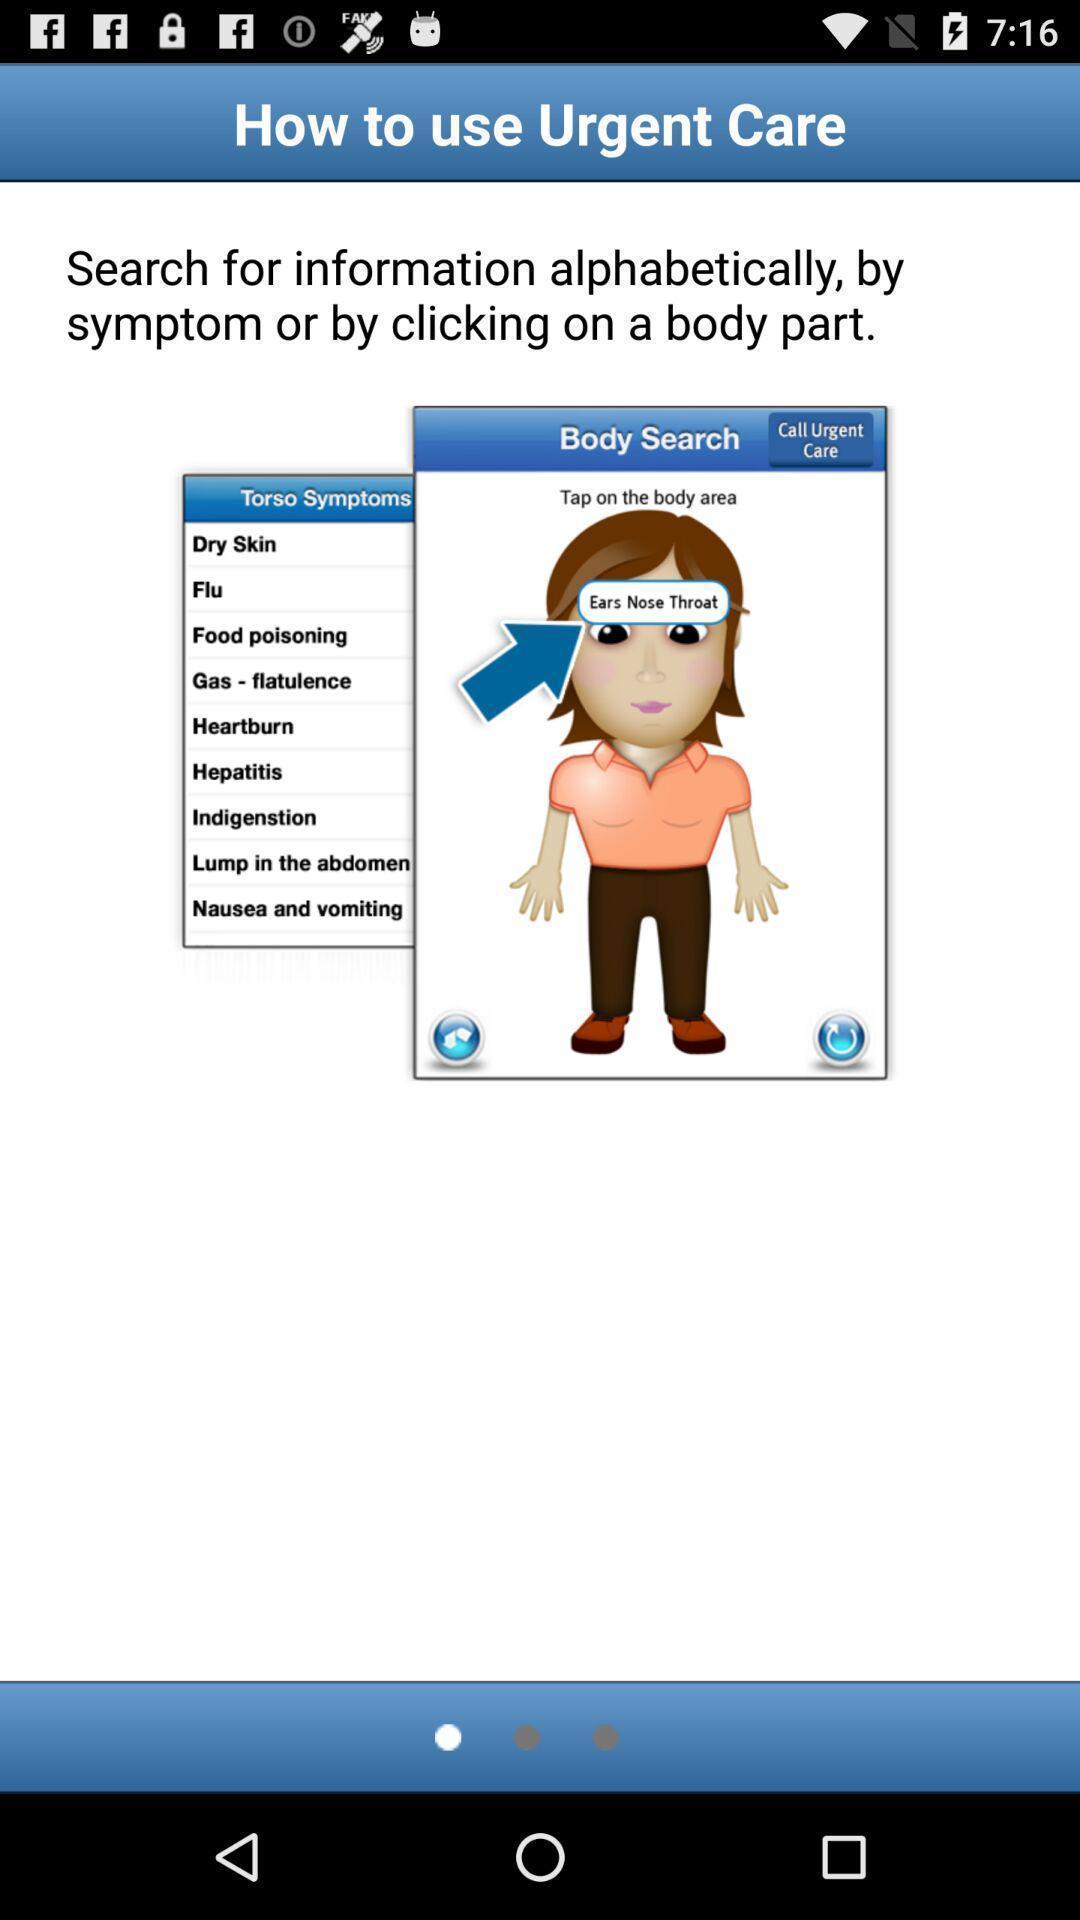Provide a description of this screenshot. Steps for urgent care of body parts in health app. 